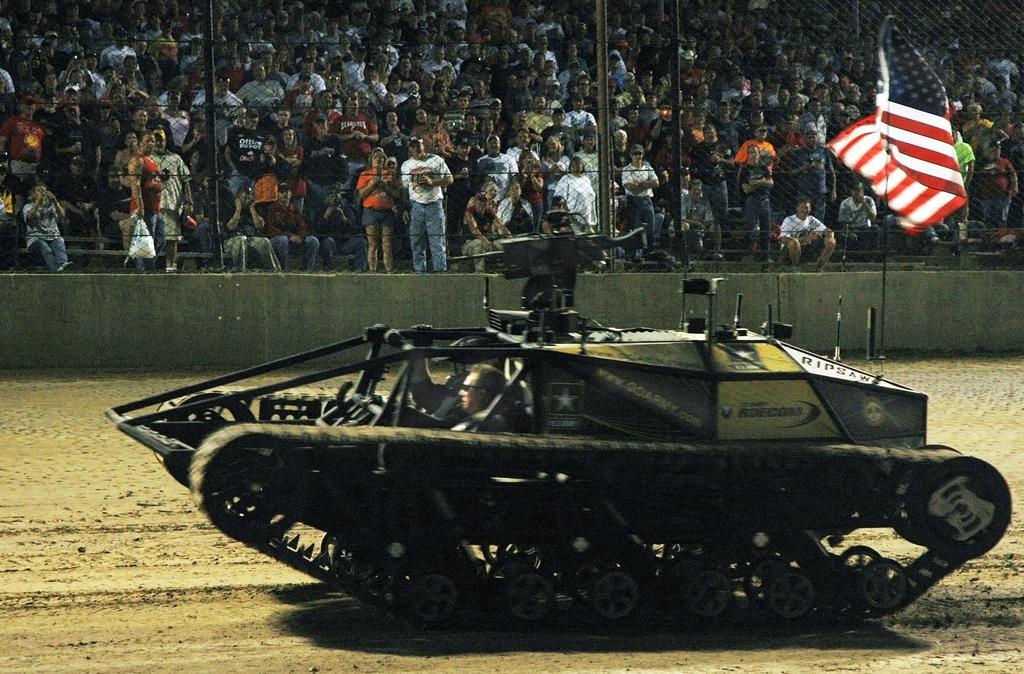Please provide a concise description of this image. In this image we can see a war tank on the ground, flag, flag post and spectators who are sitting and standing. 